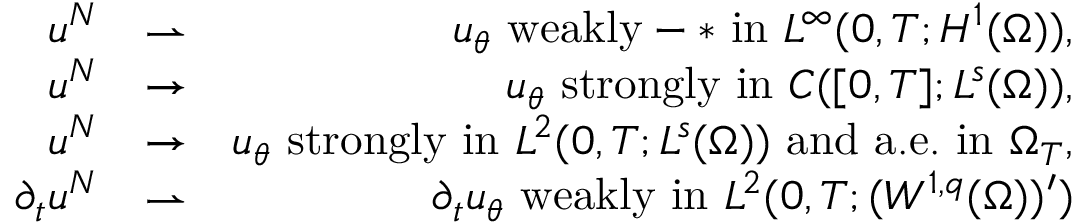Convert formula to latex. <formula><loc_0><loc_0><loc_500><loc_500>\begin{array} { r l r } { u ^ { N } } & { \rightharpoonup } & { u _ { \theta } w e a k l y - * i n L ^ { \infty } ( 0 , T ; H ^ { 1 } ( \Omega ) ) , } \\ { u ^ { N } } & { \rightarrow } & { u _ { \theta } s t r o n g l y i n C ( [ 0 , T ] ; L ^ { s } ( \Omega ) ) , } \\ { u ^ { N } } & { \rightarrow } & { u _ { \theta } s t r o n g l y i n L ^ { 2 } ( 0 , T ; L ^ { s } ( \Omega ) ) a n d a . e . i n \Omega _ { T } , } \\ { \partial _ { t } u ^ { N } } & { \rightharpoonup } & { \partial _ { t } u _ { \theta } w e a k l y i n L ^ { 2 } ( 0 , T ; ( W ^ { 1 , q } ( \Omega ) ) ^ { \prime } ) } \end{array}</formula> 